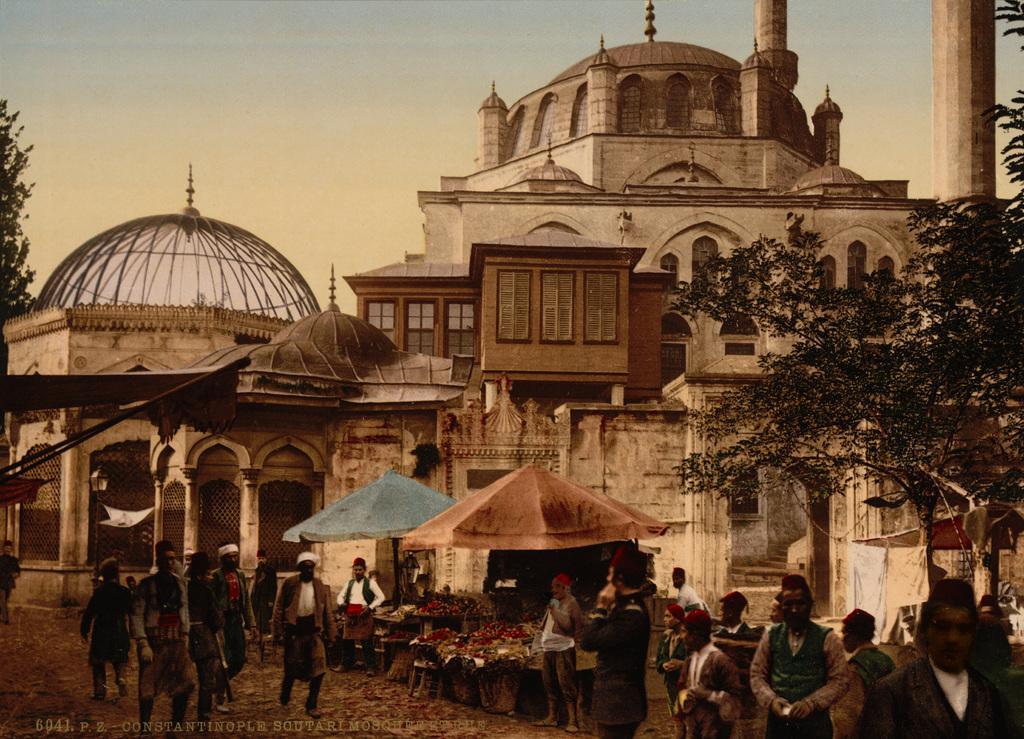In one or two sentences, can you explain what this image depicts? In this picture we can see group of people, in the background we can find tents, trees and buildings, in the bottom left hand corner we can see some text. 